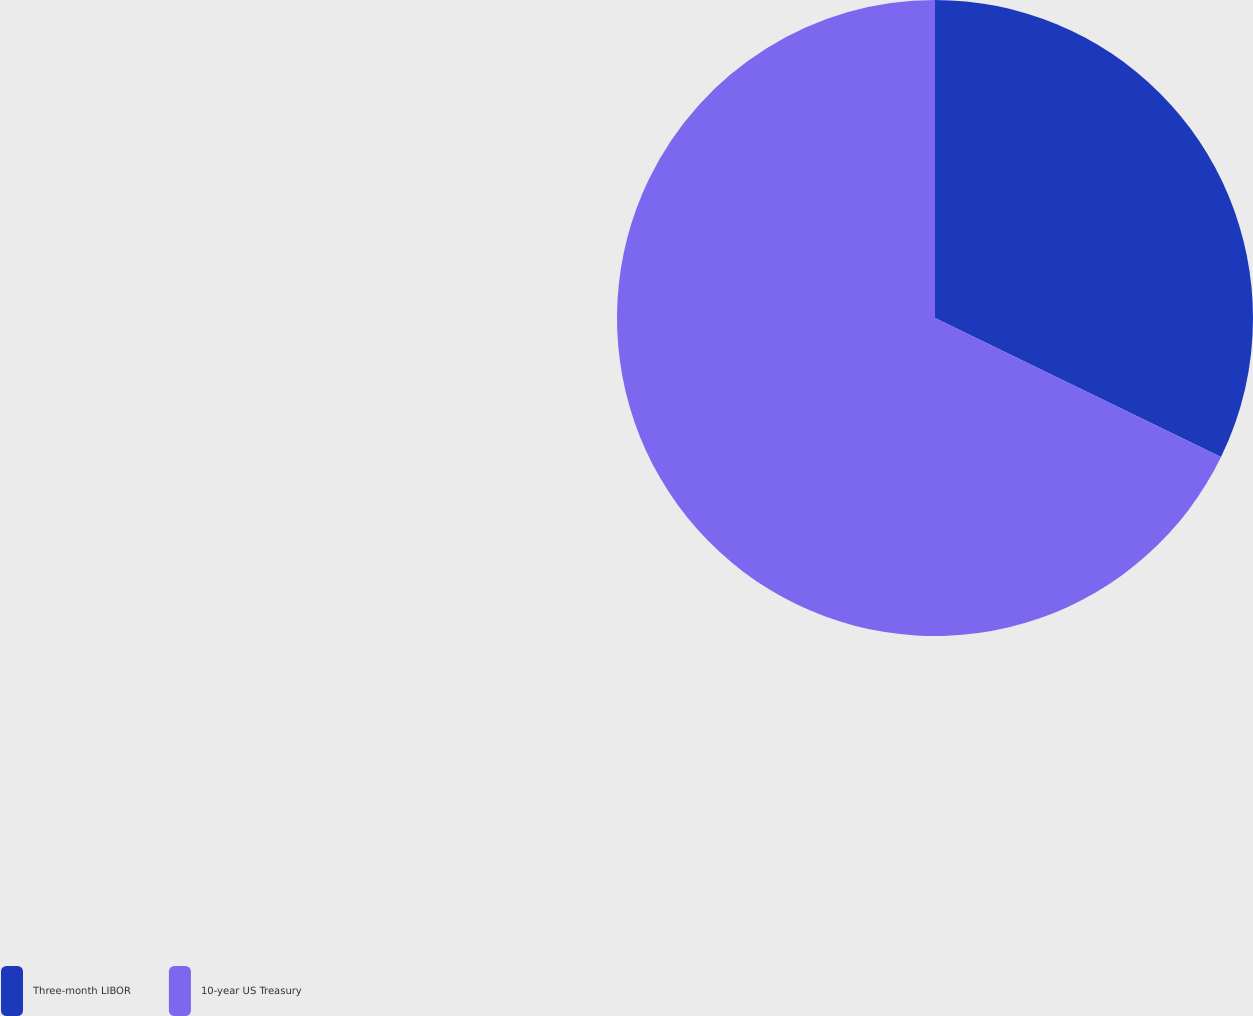Convert chart to OTSL. <chart><loc_0><loc_0><loc_500><loc_500><pie_chart><fcel>Three-month LIBOR<fcel>10-year US Treasury<nl><fcel>32.2%<fcel>67.8%<nl></chart> 